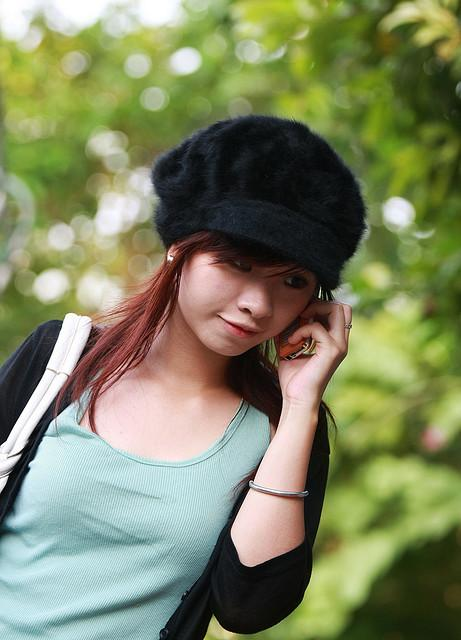Who speaks at this moment?

Choices:
A) girl
B) no one
C) clowns
D) caller caller 